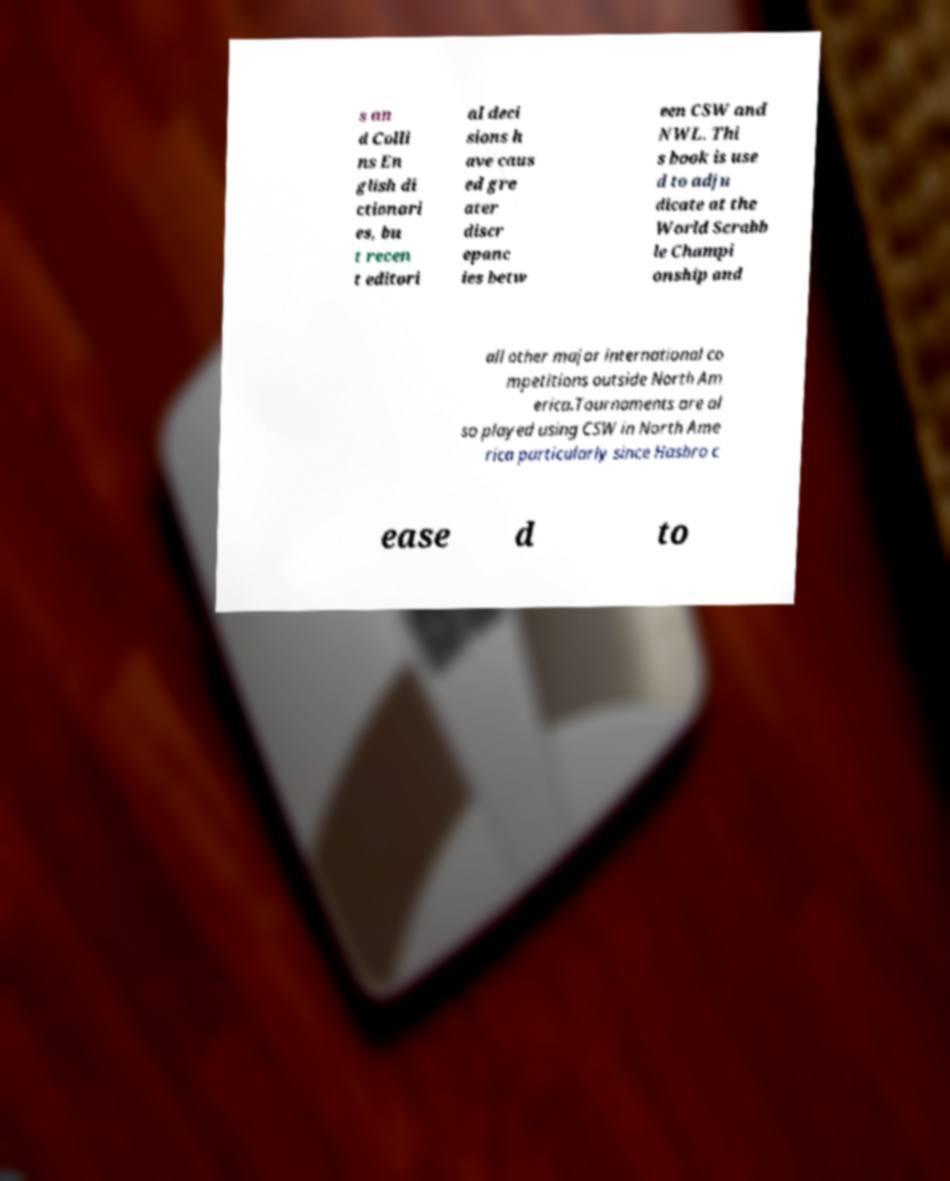There's text embedded in this image that I need extracted. Can you transcribe it verbatim? s an d Colli ns En glish di ctionari es, bu t recen t editori al deci sions h ave caus ed gre ater discr epanc ies betw een CSW and NWL. Thi s book is use d to adju dicate at the World Scrabb le Champi onship and all other major international co mpetitions outside North Am erica.Tournaments are al so played using CSW in North Ame rica particularly since Hasbro c ease d to 